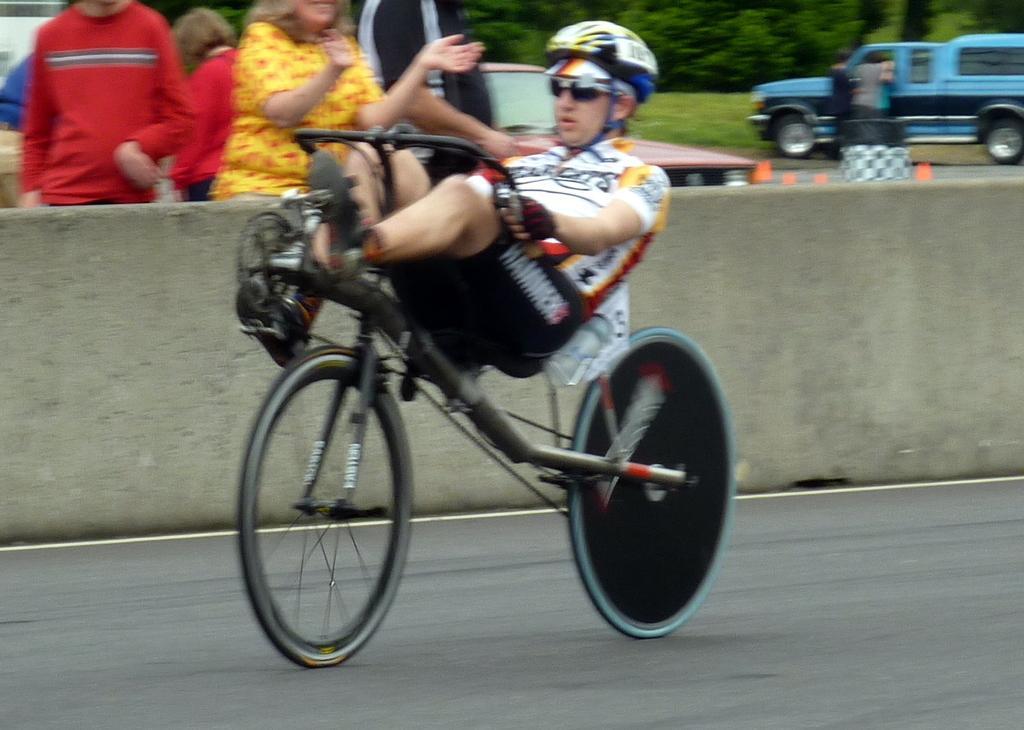How would you summarize this image in a sentence or two? In this image I can see a man is cycling a cycle, I can also see he is hearing shades and a helmet. In the background I can see few more people and a vehicle. Here I can see number of trees. 